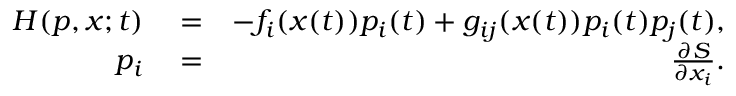<formula> <loc_0><loc_0><loc_500><loc_500>\begin{array} { r l r } { H ( p , x ; t ) } & = } & { - f _ { i } ( x ( t ) ) p _ { i } ( t ) + g _ { i j } ( x ( t ) ) p _ { i } ( t ) p _ { j } ( t ) , } \\ { p _ { i } } & = } & { \frac { \partial S } { \partial x _ { i } } . } \end{array}</formula> 